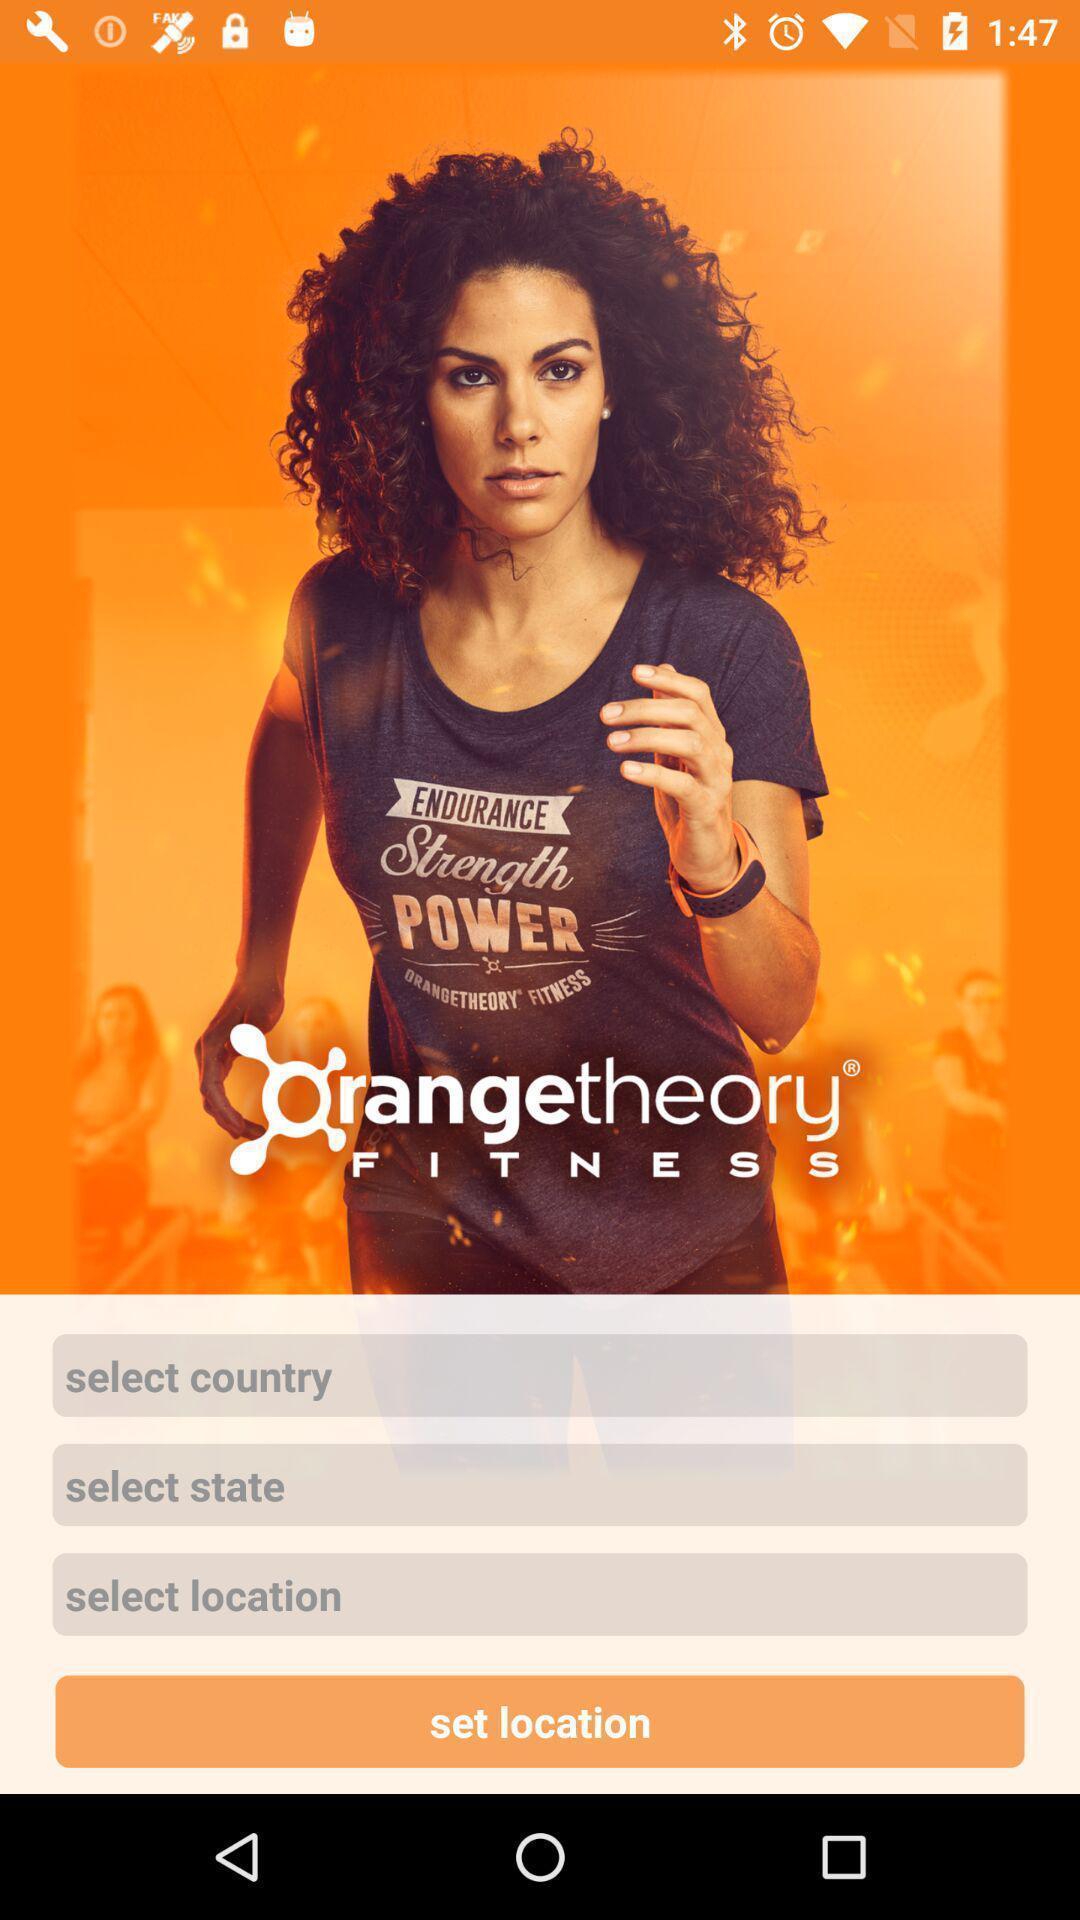Please provide a description for this image. Welcome page of a fitness application. 